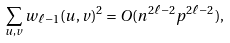Convert formula to latex. <formula><loc_0><loc_0><loc_500><loc_500>\sum _ { u , v } w _ { \ell - 1 } ( u , v ) ^ { 2 } = O ( n ^ { 2 \ell - 2 } p ^ { 2 \ell - 2 } ) ,</formula> 